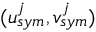Convert formula to latex. <formula><loc_0><loc_0><loc_500><loc_500>( u _ { s y m } ^ { j } , v _ { s y m } ^ { j } )</formula> 